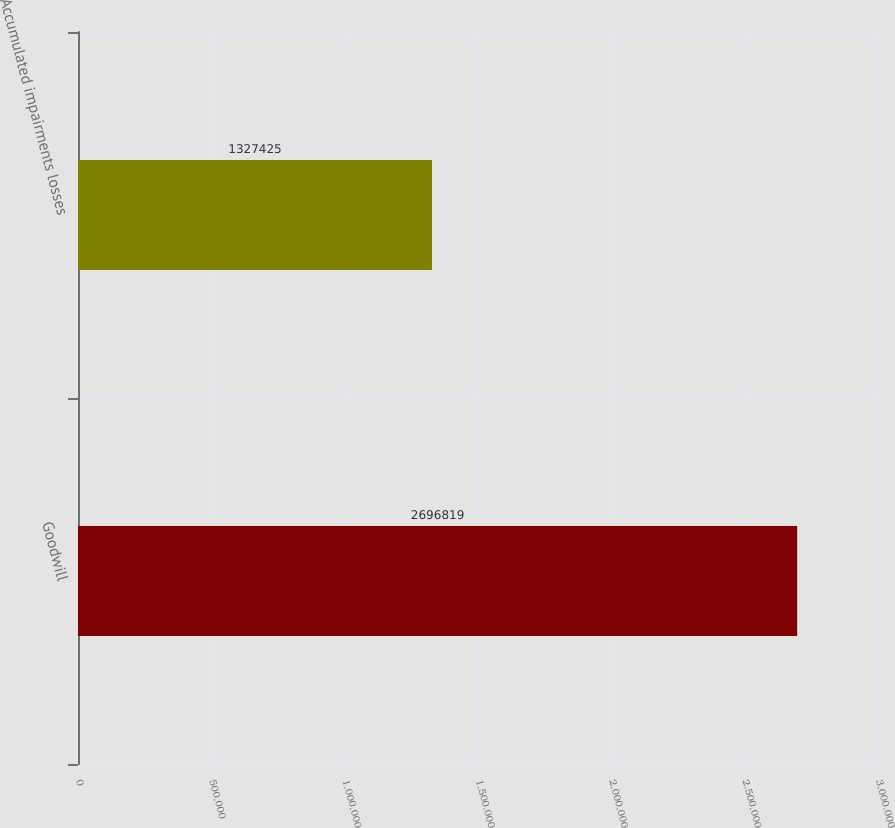Convert chart. <chart><loc_0><loc_0><loc_500><loc_500><bar_chart><fcel>Goodwill<fcel>Accumulated impairments losses<nl><fcel>2.69682e+06<fcel>1.32742e+06<nl></chart> 